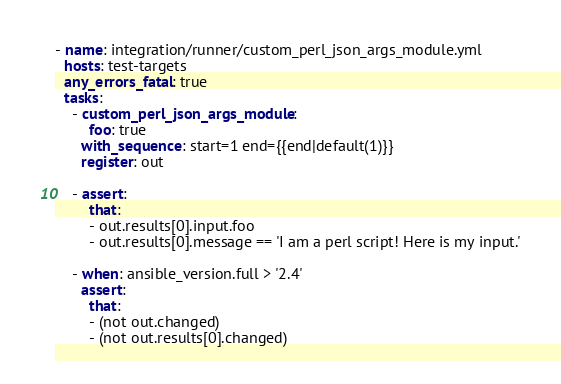<code> <loc_0><loc_0><loc_500><loc_500><_YAML_>- name: integration/runner/custom_perl_json_args_module.yml
  hosts: test-targets
  any_errors_fatal: true
  tasks:
    - custom_perl_json_args_module:
        foo: true
      with_sequence: start=1 end={{end|default(1)}}
      register: out

    - assert:
        that:
        - out.results[0].input.foo
        - out.results[0].message == 'I am a perl script! Here is my input.'

    - when: ansible_version.full > '2.4'
      assert:
        that:
        - (not out.changed)
        - (not out.results[0].changed)
</code> 